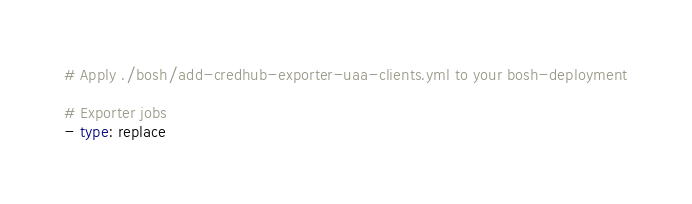<code> <loc_0><loc_0><loc_500><loc_500><_YAML_># Apply ./bosh/add-credhub-exporter-uaa-clients.yml to your bosh-deployment

# Exporter jobs
- type: replace</code> 